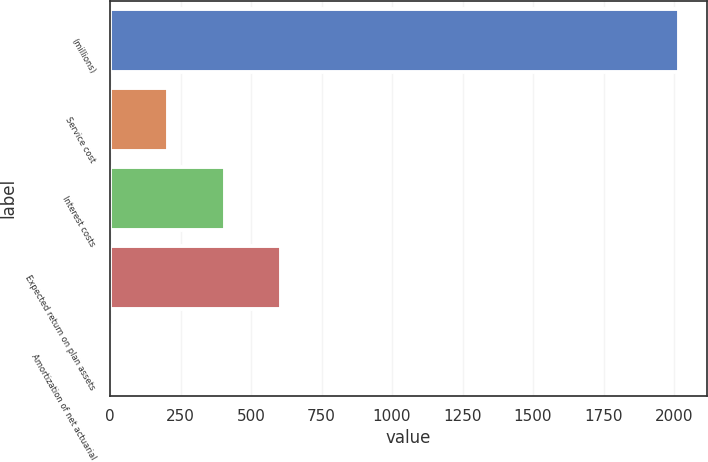Convert chart. <chart><loc_0><loc_0><loc_500><loc_500><bar_chart><fcel>(millions)<fcel>Service cost<fcel>Interest costs<fcel>Expected return on plan assets<fcel>Amortization of net actuarial<nl><fcel>2016<fcel>205.29<fcel>406.48<fcel>607.67<fcel>4.1<nl></chart> 